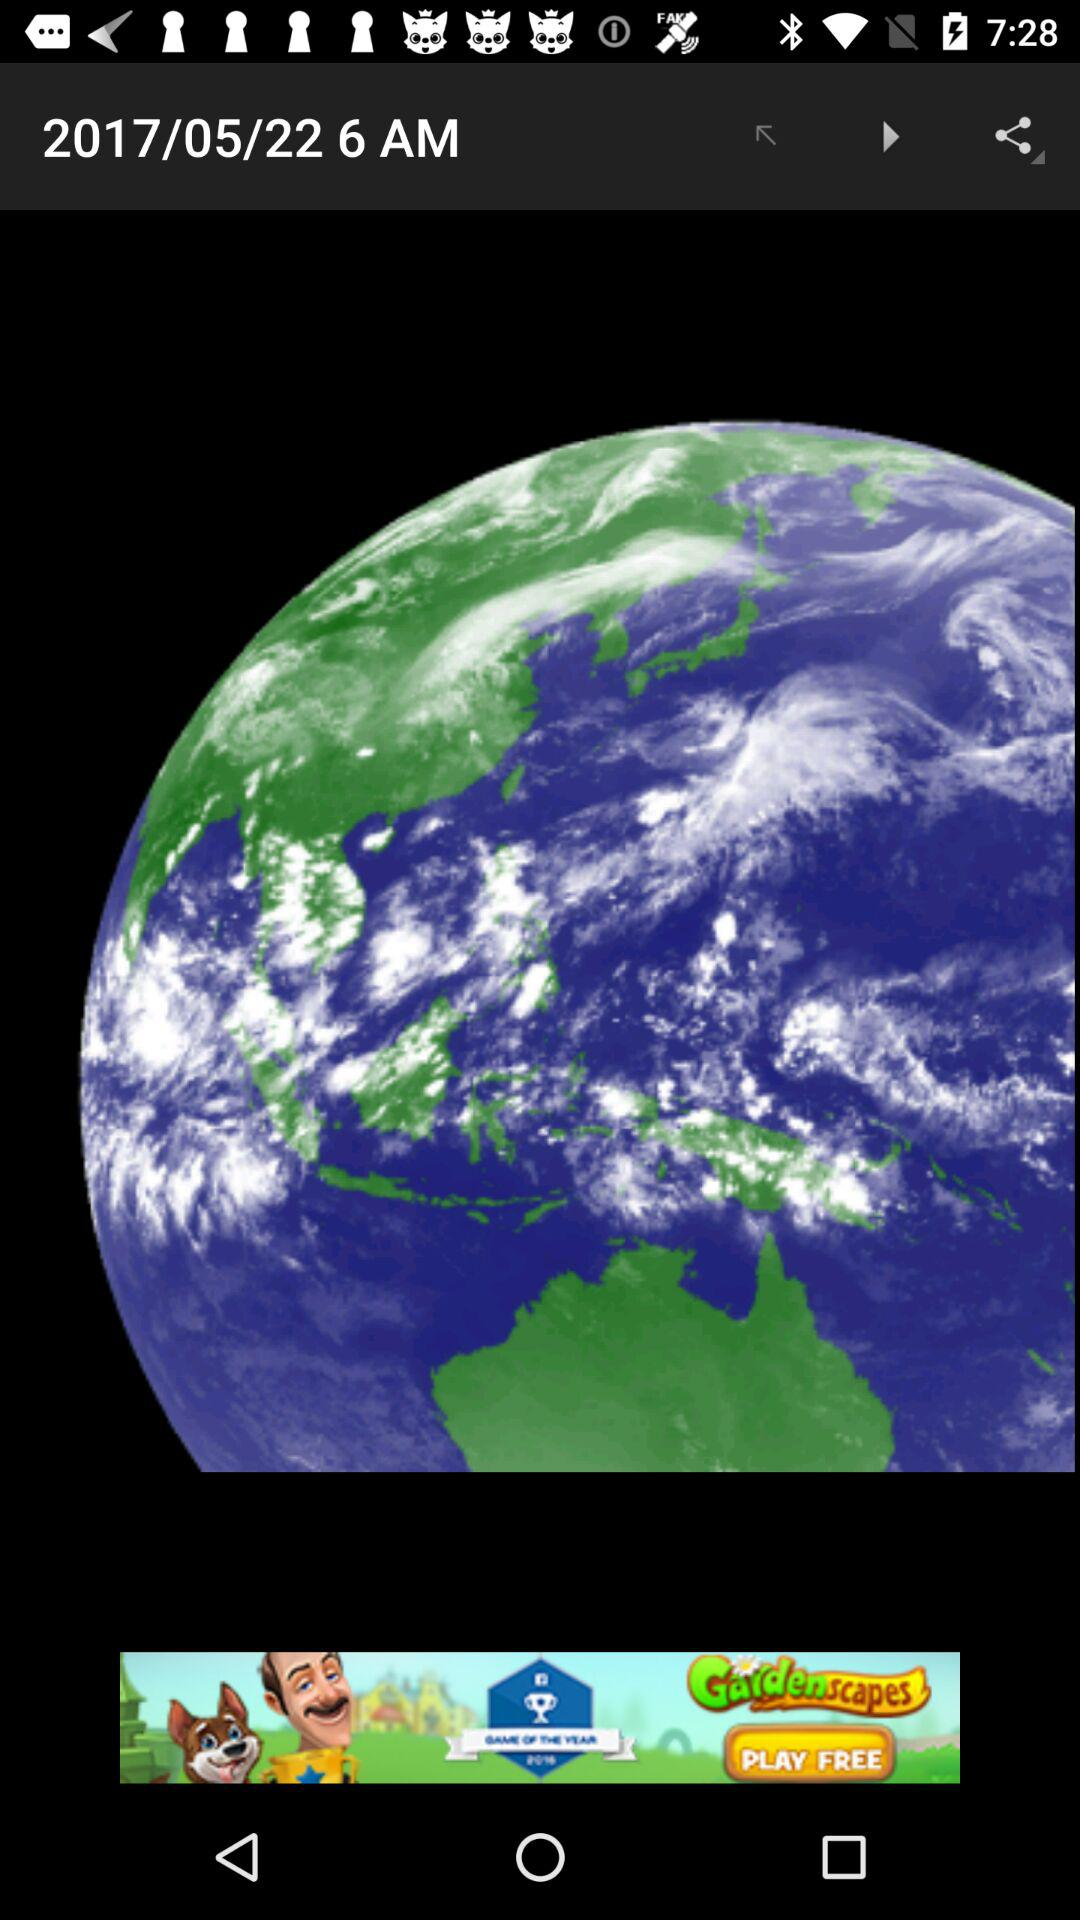What is the selected location?
When the provided information is insufficient, respond with <no answer>. <no answer> 